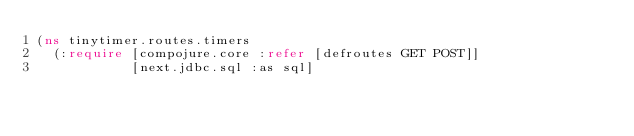<code> <loc_0><loc_0><loc_500><loc_500><_Clojure_>(ns tinytimer.routes.timers
  (:require [compojure.core :refer [defroutes GET POST]]
            [next.jdbc.sql :as sql]</code> 